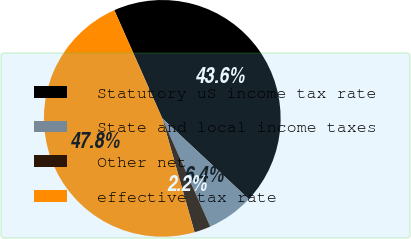Convert chart. <chart><loc_0><loc_0><loc_500><loc_500><pie_chart><fcel>Statutory uS income tax rate<fcel>State and local income taxes<fcel>Other net<fcel>effective tax rate<nl><fcel>43.59%<fcel>6.41%<fcel>2.24%<fcel>47.76%<nl></chart> 